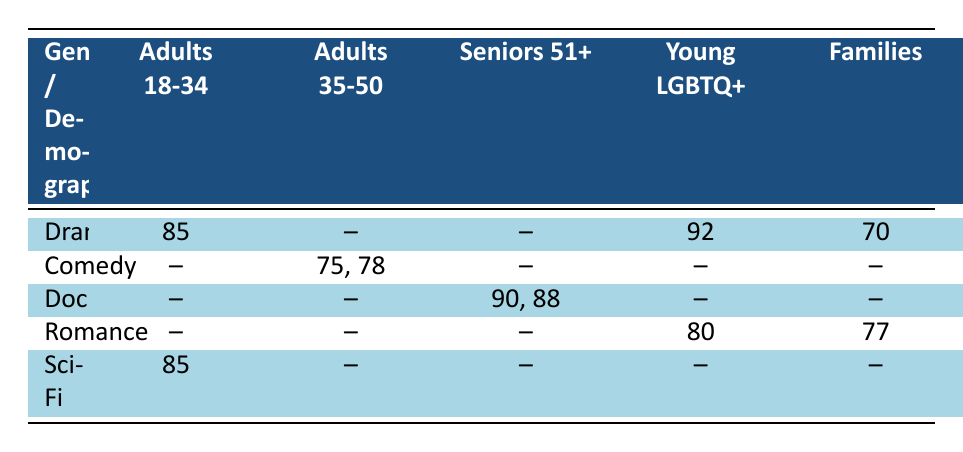What is the viewer rating for the film "Breaking Barriers"? The viewer rating for "Breaking Barriers" is found in the "Drama" row under the "Young LGBTQ+" column. The specific value is 92.
Answer: 92 Which demographic group gave the highest rating to a documentary film? The documentary films listed are "The Great Migration" with a rating of 90 for "Seniors 51+" and "Ancestral Echoes" with a rating of 88 for the same group. The highest viewer rating is thus 90 from "The Great Migration" for the "Seniors 51+" demographic.
Answer: Seniors 51+ rated documentaries the highest with a score of 90 Is there any comedy film that received ratings from the "Young LGBTQ+" demographic? From the table, all comedy films listed do not have a rating provided for the "Young LGBTQ+" demographic group. Therefore, there are no ratings to report.
Answer: No What is the average viewer rating for all the drama films listed? The drama films and their ratings are "Moosehide" with 85, "Breaking Barriers" with 92, and "Harvest Moon" with 70. The sum is 85 + 92 + 70 = 247. There are 3 drama films, so the average rating is 247 / 3 = 82.33.
Answer: 82.33 Which genre received the highest rating from adults aged 18-34? Among the ratings for adults aged 18-34 in the table, "Moosehide" and "Tech Noir," both in the Drama and Sci-Fi genres respectively, both scored 85. Therefore, the highest rating for this demographic is 85, which belongs to both Drama and Sci-Fi genres.
Answer: 85 Which demographic group had no ratings shown for the Comedy genre? In the table, the Comedy genre shows ratings for "Adults 35-50" (75 and 78), but there are no entries for "Adults 18-34," "Seniors 51+," "Young LGBTQ+," or "Families." Hence, all these groups except for "Adults 35-50" had no ratings for Comedy.
Answer: Multiple groups (Adults 18-34, Seniors 51+, Young LGBTQ+, Families) had no ratings What is the total viewer rating for all romance films? The romance films are "Queer Love in the North" with a rating of 80 and "Family Ties" with a rating of 77. The total rating is calculated by summing these two values: 80 + 77 = 157.
Answer: 157 Which genre has the lowest viewer rating from the families demographic group? The table indicates that the viewer ratings for Families in the genres listed are 70 for Drama and 77 for Romance, and there are no ratings for Comedy, Documentary, or Sci-Fi. The lowest rating provided is therefore 70 for Drama.
Answer: Drama has the lowest rating with 70 